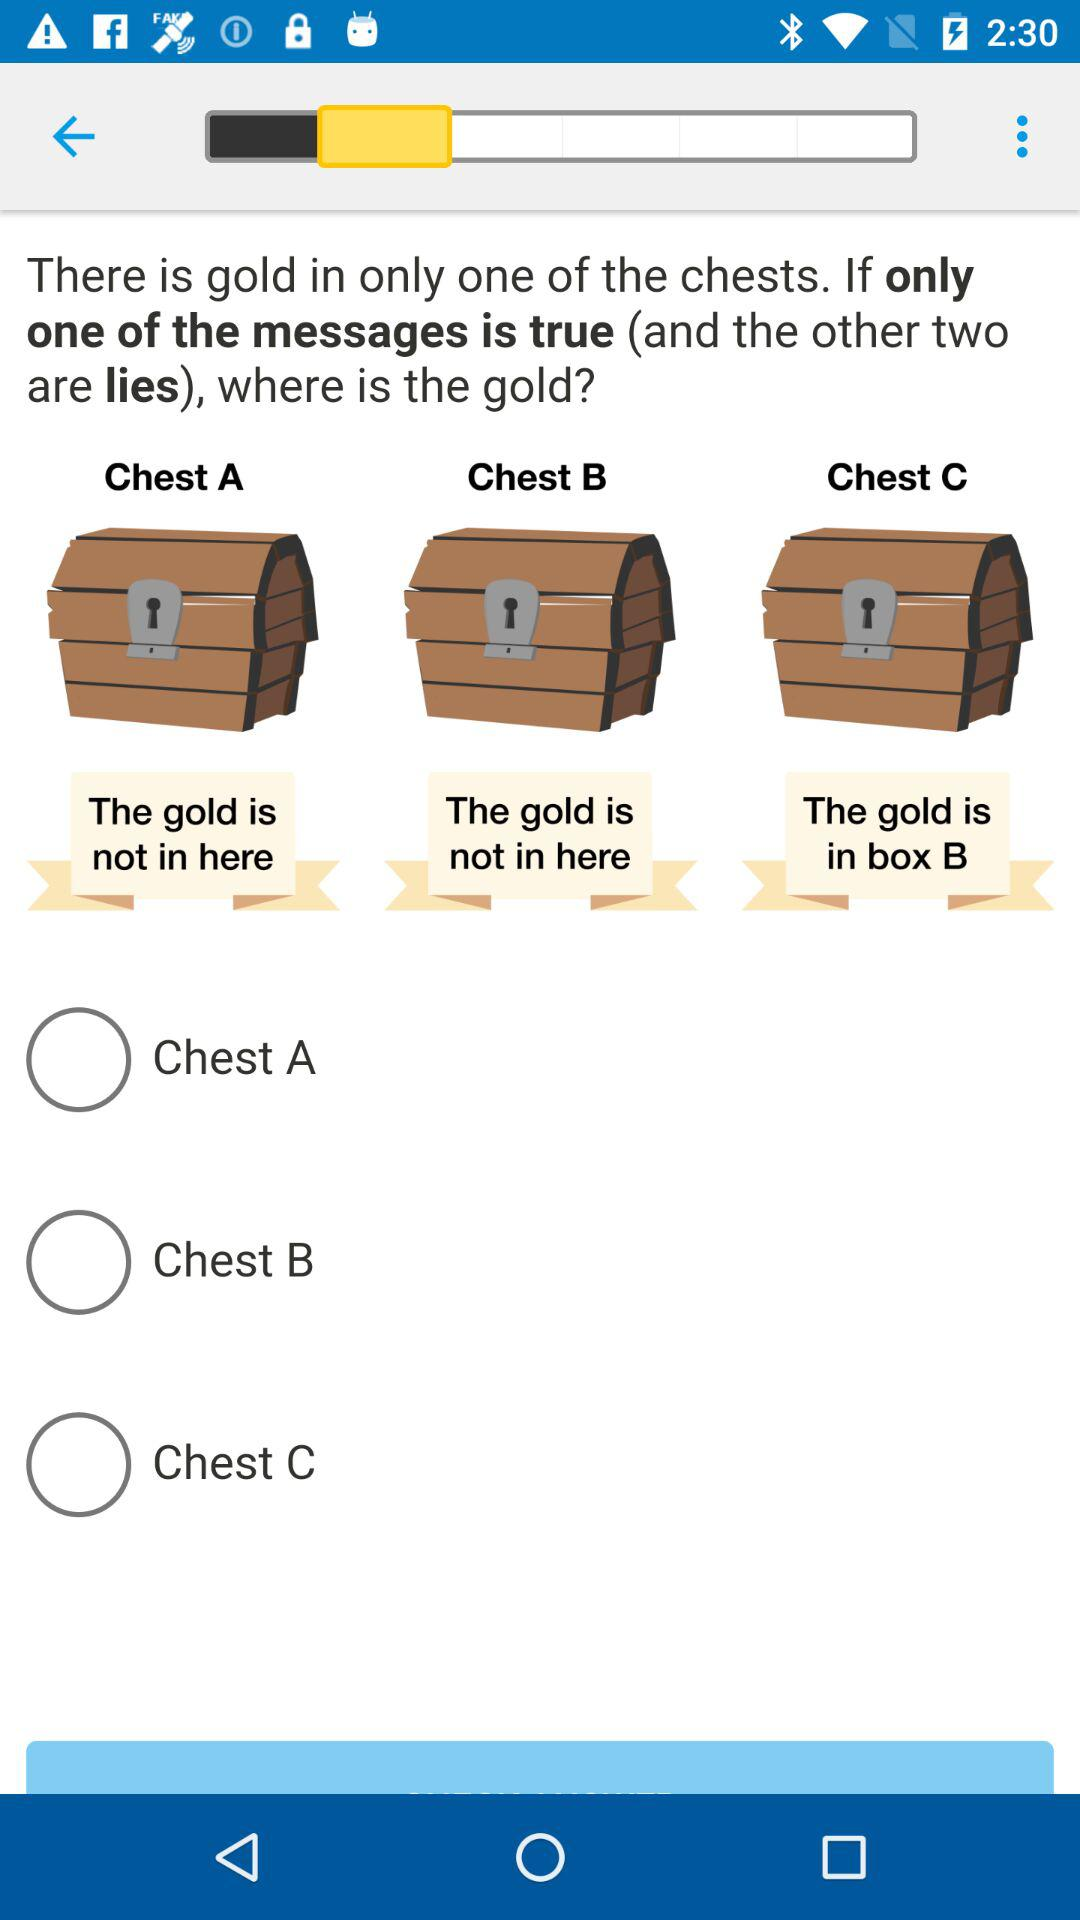How many chests have the text 'The gold is not in here'?
Answer the question using a single word or phrase. 2 